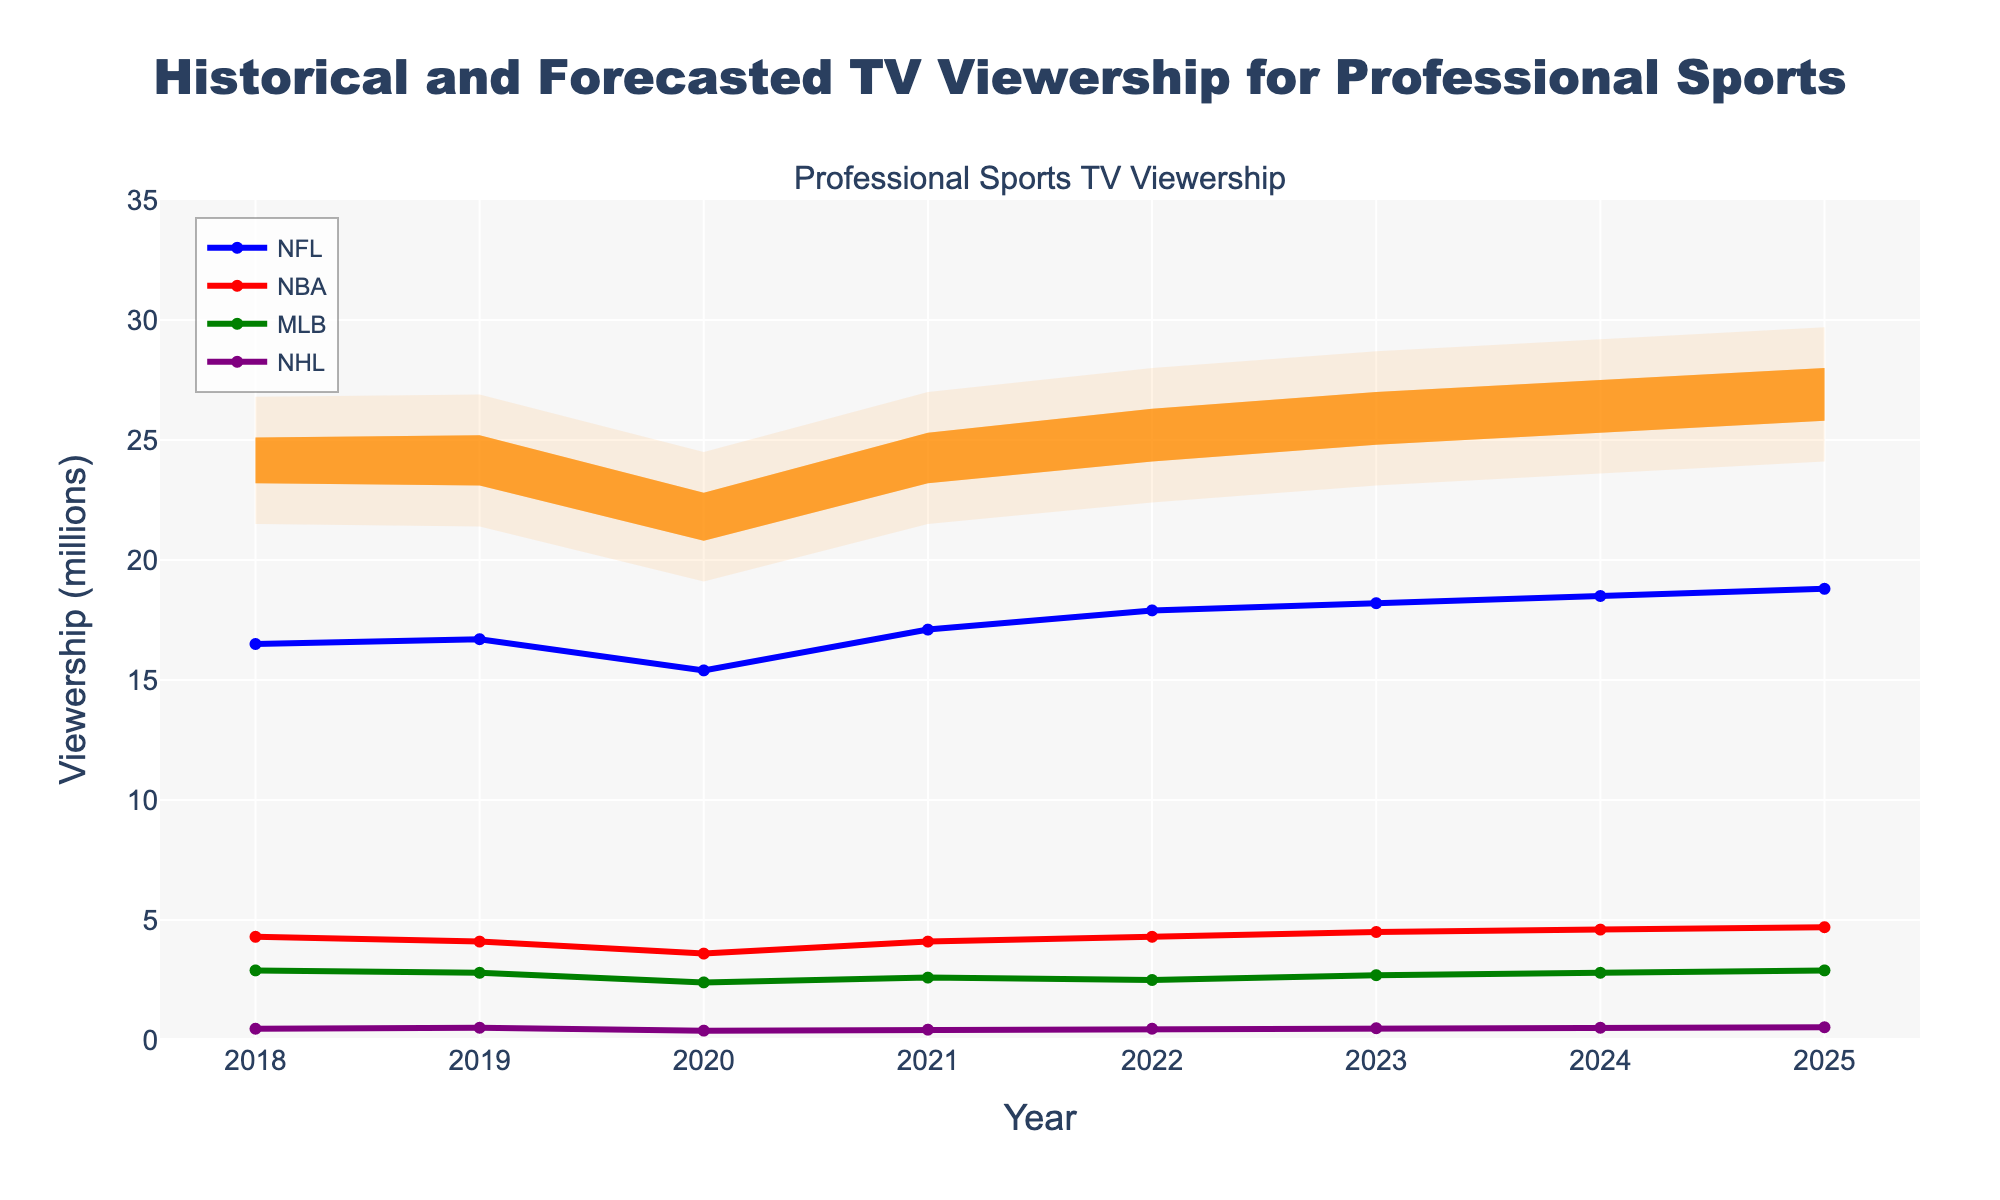What is the title of the chart? The title is usually found at the top of the chart. Here, it's explicitly shown in large, bold text.
Answer: Historical and Forecasted TV Viewership for Professional Sports Which sport had the highest viewership in 2023? By examining the 2023 data points, the NFL line is at 18.2 million, which is the highest among the sports lines (NBA, MLB, NHL).
Answer: NFL What is the range of viewership forecasted for 2025 according to the fan chart's percentiles? The fan chart overlays percentiles for a range of years. For 2025, the 10th percentile is at 24.1 million, and the 90th percentile is at 29.7 million, deduced by checking the spread of the fan chart in that year.
Answer: 24.1 to 29.7 million How did NFL viewership change from historical 2018 to forecasted 2025? Compare NFL viewership in 2018 (16.5 million) to 2025 (18.8 million) by checking the lines marked for NFL across the years.
Answer: Increased by 2.3 million What's the difference between the median total viewership and the highest single sport's viewership in 2021? For 2021, the median viewership is 24.23 million. The highest single sport viewership is NFL with 17.1 million. Subtract the NFL viewership from the median viewership.
Answer: 7.13 million Which sport's viewership trend appears to be the most stable over the years shown? Looking at the graph, MLB's viewership line fluctuates the least over the years compared to other sports.
Answer: MLB What is the expected median viewership for 2024? The median viewership in 2024 can be found along the median line of the fan chart, which is indicated as 26.41 million.
Answer: 26.41 million Between which years did the median forecasted viewership first exceed 25 million? From the graph, observe the median line of the fan chart crossing 25 million between the years. The crossing happens between 2022 and 2023.
Answer: 2022 and 2023 How much did NBA viewership increase from 2020 to 2023? Compare NBA viewership in 2020 (3.6 million) to 2023 (4.5 million) by looking at the NBA line for the respective years.
Answer: Increased by 0.9 million 